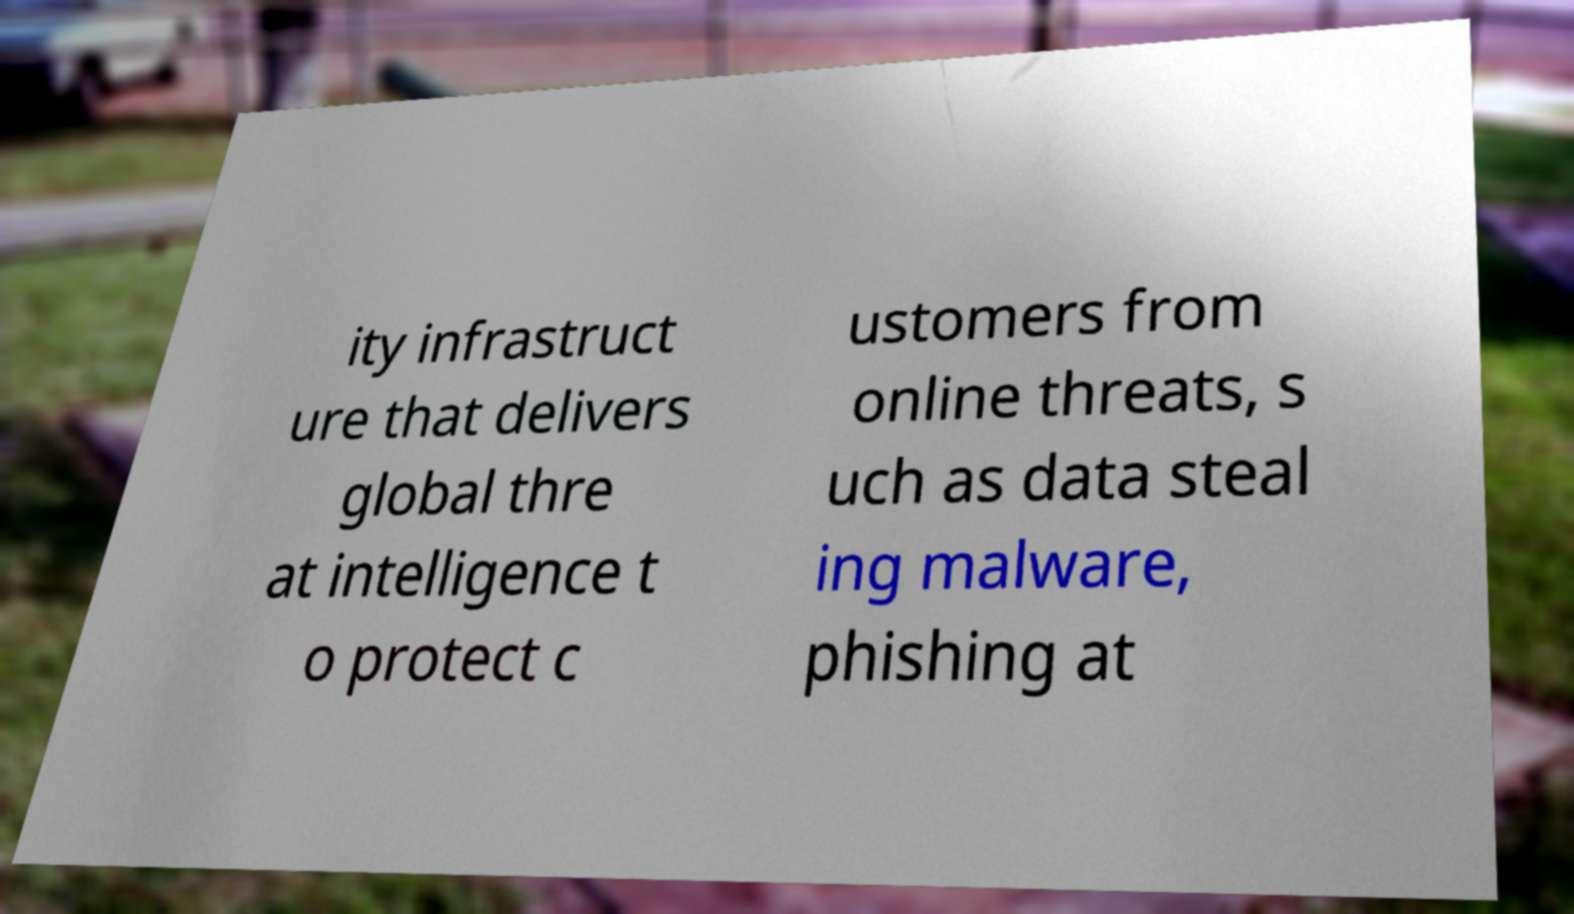Please read and relay the text visible in this image. What does it say? ity infrastruct ure that delivers global thre at intelligence t o protect c ustomers from online threats, s uch as data steal ing malware, phishing at 